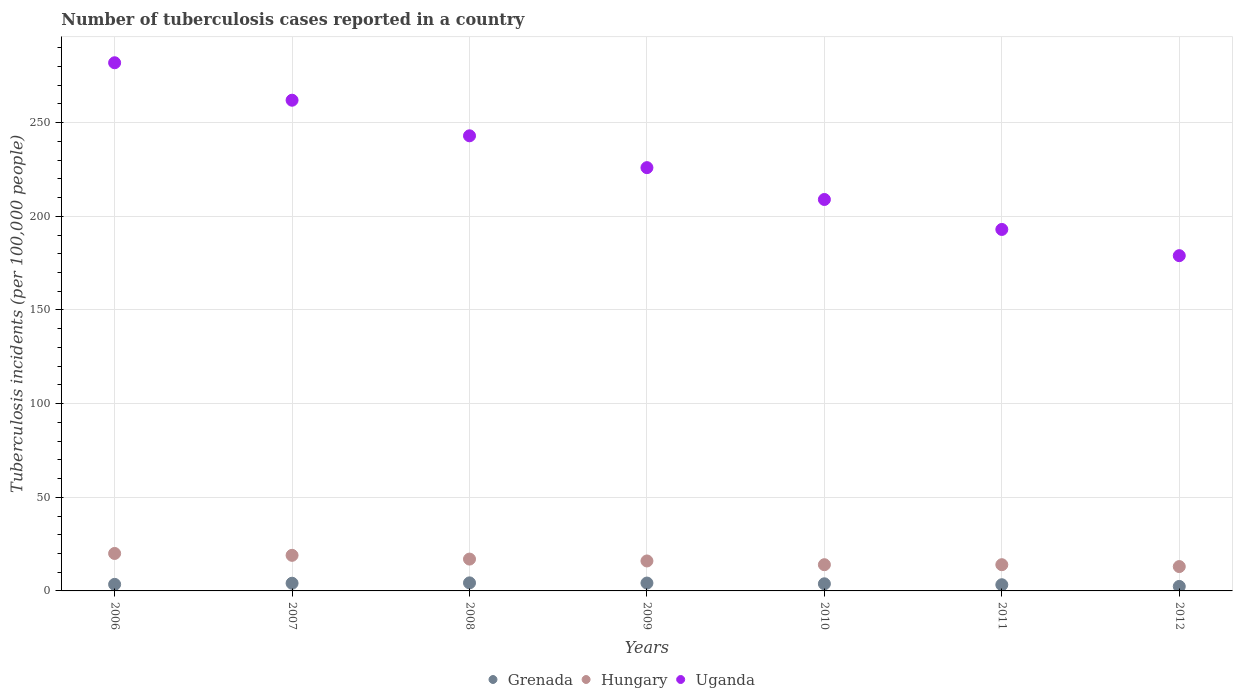How many different coloured dotlines are there?
Your answer should be compact. 3. What is the number of tuberculosis cases reported in in Hungary in 2008?
Ensure brevity in your answer.  17. Across all years, what is the maximum number of tuberculosis cases reported in in Hungary?
Give a very brief answer. 20. Across all years, what is the minimum number of tuberculosis cases reported in in Uganda?
Make the answer very short. 179. In which year was the number of tuberculosis cases reported in in Grenada maximum?
Your answer should be very brief. 2008. What is the total number of tuberculosis cases reported in in Hungary in the graph?
Give a very brief answer. 113. What is the difference between the number of tuberculosis cases reported in in Hungary in 2006 and that in 2012?
Your answer should be very brief. 7. What is the difference between the number of tuberculosis cases reported in in Uganda in 2007 and the number of tuberculosis cases reported in in Hungary in 2008?
Your answer should be compact. 245. What is the average number of tuberculosis cases reported in in Hungary per year?
Give a very brief answer. 16.14. In the year 2007, what is the difference between the number of tuberculosis cases reported in in Uganda and number of tuberculosis cases reported in in Grenada?
Your answer should be very brief. 257.9. In how many years, is the number of tuberculosis cases reported in in Grenada greater than 220?
Provide a short and direct response. 0. What is the ratio of the number of tuberculosis cases reported in in Hungary in 2007 to that in 2011?
Provide a short and direct response. 1.36. What is the difference between the highest and the second highest number of tuberculosis cases reported in in Hungary?
Keep it short and to the point. 1. What is the difference between the highest and the lowest number of tuberculosis cases reported in in Hungary?
Your response must be concise. 7. Is it the case that in every year, the sum of the number of tuberculosis cases reported in in Hungary and number of tuberculosis cases reported in in Grenada  is greater than the number of tuberculosis cases reported in in Uganda?
Offer a terse response. No. How many dotlines are there?
Keep it short and to the point. 3. What is the difference between two consecutive major ticks on the Y-axis?
Offer a very short reply. 50. Does the graph contain any zero values?
Your response must be concise. No. Does the graph contain grids?
Make the answer very short. Yes. Where does the legend appear in the graph?
Give a very brief answer. Bottom center. How many legend labels are there?
Your answer should be compact. 3. What is the title of the graph?
Keep it short and to the point. Number of tuberculosis cases reported in a country. What is the label or title of the X-axis?
Keep it short and to the point. Years. What is the label or title of the Y-axis?
Give a very brief answer. Tuberculosis incidents (per 100,0 people). What is the Tuberculosis incidents (per 100,000 people) in Hungary in 2006?
Your answer should be very brief. 20. What is the Tuberculosis incidents (per 100,000 people) of Uganda in 2006?
Your response must be concise. 282. What is the Tuberculosis incidents (per 100,000 people) of Grenada in 2007?
Give a very brief answer. 4.1. What is the Tuberculosis incidents (per 100,000 people) of Hungary in 2007?
Your answer should be very brief. 19. What is the Tuberculosis incidents (per 100,000 people) in Uganda in 2007?
Ensure brevity in your answer.  262. What is the Tuberculosis incidents (per 100,000 people) in Grenada in 2008?
Your response must be concise. 4.3. What is the Tuberculosis incidents (per 100,000 people) in Hungary in 2008?
Your response must be concise. 17. What is the Tuberculosis incidents (per 100,000 people) of Uganda in 2008?
Keep it short and to the point. 243. What is the Tuberculosis incidents (per 100,000 people) in Uganda in 2009?
Your answer should be very brief. 226. What is the Tuberculosis incidents (per 100,000 people) in Uganda in 2010?
Your response must be concise. 209. What is the Tuberculosis incidents (per 100,000 people) of Hungary in 2011?
Your response must be concise. 14. What is the Tuberculosis incidents (per 100,000 people) in Uganda in 2011?
Offer a terse response. 193. What is the Tuberculosis incidents (per 100,000 people) in Hungary in 2012?
Ensure brevity in your answer.  13. What is the Tuberculosis incidents (per 100,000 people) in Uganda in 2012?
Make the answer very short. 179. Across all years, what is the maximum Tuberculosis incidents (per 100,000 people) of Uganda?
Make the answer very short. 282. Across all years, what is the minimum Tuberculosis incidents (per 100,000 people) of Grenada?
Provide a short and direct response. 2.4. Across all years, what is the minimum Tuberculosis incidents (per 100,000 people) of Hungary?
Provide a short and direct response. 13. Across all years, what is the minimum Tuberculosis incidents (per 100,000 people) in Uganda?
Provide a succinct answer. 179. What is the total Tuberculosis incidents (per 100,000 people) of Grenada in the graph?
Your answer should be very brief. 25.6. What is the total Tuberculosis incidents (per 100,000 people) in Hungary in the graph?
Give a very brief answer. 113. What is the total Tuberculosis incidents (per 100,000 people) of Uganda in the graph?
Give a very brief answer. 1594. What is the difference between the Tuberculosis incidents (per 100,000 people) in Grenada in 2006 and that in 2007?
Provide a succinct answer. -0.6. What is the difference between the Tuberculosis incidents (per 100,000 people) in Grenada in 2006 and that in 2008?
Ensure brevity in your answer.  -0.8. What is the difference between the Tuberculosis incidents (per 100,000 people) of Uganda in 2006 and that in 2008?
Your answer should be very brief. 39. What is the difference between the Tuberculosis incidents (per 100,000 people) in Grenada in 2006 and that in 2009?
Keep it short and to the point. -0.7. What is the difference between the Tuberculosis incidents (per 100,000 people) of Hungary in 2006 and that in 2010?
Your response must be concise. 6. What is the difference between the Tuberculosis incidents (per 100,000 people) of Grenada in 2006 and that in 2011?
Keep it short and to the point. 0.2. What is the difference between the Tuberculosis incidents (per 100,000 people) in Hungary in 2006 and that in 2011?
Offer a very short reply. 6. What is the difference between the Tuberculosis incidents (per 100,000 people) in Uganda in 2006 and that in 2011?
Ensure brevity in your answer.  89. What is the difference between the Tuberculosis incidents (per 100,000 people) of Grenada in 2006 and that in 2012?
Your answer should be very brief. 1.1. What is the difference between the Tuberculosis incidents (per 100,000 people) of Hungary in 2006 and that in 2012?
Give a very brief answer. 7. What is the difference between the Tuberculosis incidents (per 100,000 people) of Uganda in 2006 and that in 2012?
Provide a short and direct response. 103. What is the difference between the Tuberculosis incidents (per 100,000 people) of Hungary in 2007 and that in 2008?
Your answer should be compact. 2. What is the difference between the Tuberculosis incidents (per 100,000 people) of Grenada in 2007 and that in 2009?
Keep it short and to the point. -0.1. What is the difference between the Tuberculosis incidents (per 100,000 people) of Hungary in 2007 and that in 2009?
Give a very brief answer. 3. What is the difference between the Tuberculosis incidents (per 100,000 people) of Uganda in 2007 and that in 2009?
Your answer should be compact. 36. What is the difference between the Tuberculosis incidents (per 100,000 people) of Uganda in 2007 and that in 2010?
Your answer should be compact. 53. What is the difference between the Tuberculosis incidents (per 100,000 people) of Grenada in 2007 and that in 2011?
Your response must be concise. 0.8. What is the difference between the Tuberculosis incidents (per 100,000 people) in Uganda in 2007 and that in 2011?
Provide a short and direct response. 69. What is the difference between the Tuberculosis incidents (per 100,000 people) of Hungary in 2007 and that in 2012?
Your answer should be compact. 6. What is the difference between the Tuberculosis incidents (per 100,000 people) in Grenada in 2008 and that in 2009?
Give a very brief answer. 0.1. What is the difference between the Tuberculosis incidents (per 100,000 people) of Grenada in 2008 and that in 2010?
Your answer should be compact. 0.5. What is the difference between the Tuberculosis incidents (per 100,000 people) of Hungary in 2008 and that in 2010?
Your response must be concise. 3. What is the difference between the Tuberculosis incidents (per 100,000 people) of Uganda in 2008 and that in 2010?
Ensure brevity in your answer.  34. What is the difference between the Tuberculosis incidents (per 100,000 people) of Hungary in 2008 and that in 2011?
Your response must be concise. 3. What is the difference between the Tuberculosis incidents (per 100,000 people) in Grenada in 2008 and that in 2012?
Give a very brief answer. 1.9. What is the difference between the Tuberculosis incidents (per 100,000 people) of Uganda in 2008 and that in 2012?
Your answer should be compact. 64. What is the difference between the Tuberculosis incidents (per 100,000 people) of Hungary in 2009 and that in 2010?
Your answer should be compact. 2. What is the difference between the Tuberculosis incidents (per 100,000 people) in Uganda in 2009 and that in 2010?
Your response must be concise. 17. What is the difference between the Tuberculosis incidents (per 100,000 people) in Grenada in 2009 and that in 2011?
Offer a terse response. 0.9. What is the difference between the Tuberculosis incidents (per 100,000 people) in Hungary in 2009 and that in 2011?
Your response must be concise. 2. What is the difference between the Tuberculosis incidents (per 100,000 people) in Uganda in 2009 and that in 2011?
Ensure brevity in your answer.  33. What is the difference between the Tuberculosis incidents (per 100,000 people) of Grenada in 2009 and that in 2012?
Give a very brief answer. 1.8. What is the difference between the Tuberculosis incidents (per 100,000 people) of Hungary in 2009 and that in 2012?
Keep it short and to the point. 3. What is the difference between the Tuberculosis incidents (per 100,000 people) of Hungary in 2010 and that in 2011?
Give a very brief answer. 0. What is the difference between the Tuberculosis incidents (per 100,000 people) in Uganda in 2010 and that in 2011?
Give a very brief answer. 16. What is the difference between the Tuberculosis incidents (per 100,000 people) of Grenada in 2010 and that in 2012?
Your answer should be compact. 1.4. What is the difference between the Tuberculosis incidents (per 100,000 people) in Grenada in 2011 and that in 2012?
Your answer should be compact. 0.9. What is the difference between the Tuberculosis incidents (per 100,000 people) of Uganda in 2011 and that in 2012?
Give a very brief answer. 14. What is the difference between the Tuberculosis incidents (per 100,000 people) of Grenada in 2006 and the Tuberculosis incidents (per 100,000 people) of Hungary in 2007?
Make the answer very short. -15.5. What is the difference between the Tuberculosis incidents (per 100,000 people) of Grenada in 2006 and the Tuberculosis incidents (per 100,000 people) of Uganda in 2007?
Make the answer very short. -258.5. What is the difference between the Tuberculosis incidents (per 100,000 people) in Hungary in 2006 and the Tuberculosis incidents (per 100,000 people) in Uganda in 2007?
Provide a succinct answer. -242. What is the difference between the Tuberculosis incidents (per 100,000 people) in Grenada in 2006 and the Tuberculosis incidents (per 100,000 people) in Hungary in 2008?
Offer a very short reply. -13.5. What is the difference between the Tuberculosis incidents (per 100,000 people) of Grenada in 2006 and the Tuberculosis incidents (per 100,000 people) of Uganda in 2008?
Your response must be concise. -239.5. What is the difference between the Tuberculosis incidents (per 100,000 people) in Hungary in 2006 and the Tuberculosis incidents (per 100,000 people) in Uganda in 2008?
Provide a short and direct response. -223. What is the difference between the Tuberculosis incidents (per 100,000 people) in Grenada in 2006 and the Tuberculosis incidents (per 100,000 people) in Uganda in 2009?
Your answer should be compact. -222.5. What is the difference between the Tuberculosis incidents (per 100,000 people) in Hungary in 2006 and the Tuberculosis incidents (per 100,000 people) in Uganda in 2009?
Offer a very short reply. -206. What is the difference between the Tuberculosis incidents (per 100,000 people) of Grenada in 2006 and the Tuberculosis incidents (per 100,000 people) of Hungary in 2010?
Provide a succinct answer. -10.5. What is the difference between the Tuberculosis incidents (per 100,000 people) in Grenada in 2006 and the Tuberculosis incidents (per 100,000 people) in Uganda in 2010?
Ensure brevity in your answer.  -205.5. What is the difference between the Tuberculosis incidents (per 100,000 people) in Hungary in 2006 and the Tuberculosis incidents (per 100,000 people) in Uganda in 2010?
Offer a very short reply. -189. What is the difference between the Tuberculosis incidents (per 100,000 people) of Grenada in 2006 and the Tuberculosis incidents (per 100,000 people) of Uganda in 2011?
Make the answer very short. -189.5. What is the difference between the Tuberculosis incidents (per 100,000 people) in Hungary in 2006 and the Tuberculosis incidents (per 100,000 people) in Uganda in 2011?
Your answer should be compact. -173. What is the difference between the Tuberculosis incidents (per 100,000 people) of Grenada in 2006 and the Tuberculosis incidents (per 100,000 people) of Uganda in 2012?
Offer a terse response. -175.5. What is the difference between the Tuberculosis incidents (per 100,000 people) in Hungary in 2006 and the Tuberculosis incidents (per 100,000 people) in Uganda in 2012?
Provide a short and direct response. -159. What is the difference between the Tuberculosis incidents (per 100,000 people) of Grenada in 2007 and the Tuberculosis incidents (per 100,000 people) of Hungary in 2008?
Provide a short and direct response. -12.9. What is the difference between the Tuberculosis incidents (per 100,000 people) of Grenada in 2007 and the Tuberculosis incidents (per 100,000 people) of Uganda in 2008?
Provide a short and direct response. -238.9. What is the difference between the Tuberculosis incidents (per 100,000 people) in Hungary in 2007 and the Tuberculosis incidents (per 100,000 people) in Uganda in 2008?
Ensure brevity in your answer.  -224. What is the difference between the Tuberculosis incidents (per 100,000 people) in Grenada in 2007 and the Tuberculosis incidents (per 100,000 people) in Hungary in 2009?
Your answer should be very brief. -11.9. What is the difference between the Tuberculosis incidents (per 100,000 people) of Grenada in 2007 and the Tuberculosis incidents (per 100,000 people) of Uganda in 2009?
Provide a succinct answer. -221.9. What is the difference between the Tuberculosis incidents (per 100,000 people) in Hungary in 2007 and the Tuberculosis incidents (per 100,000 people) in Uganda in 2009?
Offer a terse response. -207. What is the difference between the Tuberculosis incidents (per 100,000 people) of Grenada in 2007 and the Tuberculosis incidents (per 100,000 people) of Hungary in 2010?
Your answer should be very brief. -9.9. What is the difference between the Tuberculosis incidents (per 100,000 people) of Grenada in 2007 and the Tuberculosis incidents (per 100,000 people) of Uganda in 2010?
Your answer should be very brief. -204.9. What is the difference between the Tuberculosis incidents (per 100,000 people) of Hungary in 2007 and the Tuberculosis incidents (per 100,000 people) of Uganda in 2010?
Your response must be concise. -190. What is the difference between the Tuberculosis incidents (per 100,000 people) in Grenada in 2007 and the Tuberculosis incidents (per 100,000 people) in Hungary in 2011?
Provide a succinct answer. -9.9. What is the difference between the Tuberculosis incidents (per 100,000 people) in Grenada in 2007 and the Tuberculosis incidents (per 100,000 people) in Uganda in 2011?
Provide a short and direct response. -188.9. What is the difference between the Tuberculosis incidents (per 100,000 people) in Hungary in 2007 and the Tuberculosis incidents (per 100,000 people) in Uganda in 2011?
Your answer should be very brief. -174. What is the difference between the Tuberculosis incidents (per 100,000 people) of Grenada in 2007 and the Tuberculosis incidents (per 100,000 people) of Hungary in 2012?
Your response must be concise. -8.9. What is the difference between the Tuberculosis incidents (per 100,000 people) of Grenada in 2007 and the Tuberculosis incidents (per 100,000 people) of Uganda in 2012?
Keep it short and to the point. -174.9. What is the difference between the Tuberculosis incidents (per 100,000 people) of Hungary in 2007 and the Tuberculosis incidents (per 100,000 people) of Uganda in 2012?
Make the answer very short. -160. What is the difference between the Tuberculosis incidents (per 100,000 people) of Grenada in 2008 and the Tuberculosis incidents (per 100,000 people) of Hungary in 2009?
Offer a very short reply. -11.7. What is the difference between the Tuberculosis incidents (per 100,000 people) in Grenada in 2008 and the Tuberculosis incidents (per 100,000 people) in Uganda in 2009?
Your answer should be very brief. -221.7. What is the difference between the Tuberculosis incidents (per 100,000 people) in Hungary in 2008 and the Tuberculosis incidents (per 100,000 people) in Uganda in 2009?
Offer a terse response. -209. What is the difference between the Tuberculosis incidents (per 100,000 people) of Grenada in 2008 and the Tuberculosis incidents (per 100,000 people) of Uganda in 2010?
Keep it short and to the point. -204.7. What is the difference between the Tuberculosis incidents (per 100,000 people) in Hungary in 2008 and the Tuberculosis incidents (per 100,000 people) in Uganda in 2010?
Give a very brief answer. -192. What is the difference between the Tuberculosis incidents (per 100,000 people) in Grenada in 2008 and the Tuberculosis incidents (per 100,000 people) in Uganda in 2011?
Provide a succinct answer. -188.7. What is the difference between the Tuberculosis incidents (per 100,000 people) in Hungary in 2008 and the Tuberculosis incidents (per 100,000 people) in Uganda in 2011?
Your answer should be very brief. -176. What is the difference between the Tuberculosis incidents (per 100,000 people) of Grenada in 2008 and the Tuberculosis incidents (per 100,000 people) of Uganda in 2012?
Make the answer very short. -174.7. What is the difference between the Tuberculosis incidents (per 100,000 people) of Hungary in 2008 and the Tuberculosis incidents (per 100,000 people) of Uganda in 2012?
Your response must be concise. -162. What is the difference between the Tuberculosis incidents (per 100,000 people) in Grenada in 2009 and the Tuberculosis incidents (per 100,000 people) in Hungary in 2010?
Give a very brief answer. -9.8. What is the difference between the Tuberculosis incidents (per 100,000 people) of Grenada in 2009 and the Tuberculosis incidents (per 100,000 people) of Uganda in 2010?
Offer a very short reply. -204.8. What is the difference between the Tuberculosis incidents (per 100,000 people) of Hungary in 2009 and the Tuberculosis incidents (per 100,000 people) of Uganda in 2010?
Your answer should be very brief. -193. What is the difference between the Tuberculosis incidents (per 100,000 people) of Grenada in 2009 and the Tuberculosis incidents (per 100,000 people) of Hungary in 2011?
Your answer should be very brief. -9.8. What is the difference between the Tuberculosis incidents (per 100,000 people) in Grenada in 2009 and the Tuberculosis incidents (per 100,000 people) in Uganda in 2011?
Ensure brevity in your answer.  -188.8. What is the difference between the Tuberculosis incidents (per 100,000 people) of Hungary in 2009 and the Tuberculosis incidents (per 100,000 people) of Uganda in 2011?
Your response must be concise. -177. What is the difference between the Tuberculosis incidents (per 100,000 people) of Grenada in 2009 and the Tuberculosis incidents (per 100,000 people) of Uganda in 2012?
Your answer should be very brief. -174.8. What is the difference between the Tuberculosis incidents (per 100,000 people) in Hungary in 2009 and the Tuberculosis incidents (per 100,000 people) in Uganda in 2012?
Provide a succinct answer. -163. What is the difference between the Tuberculosis incidents (per 100,000 people) in Grenada in 2010 and the Tuberculosis incidents (per 100,000 people) in Uganda in 2011?
Your answer should be very brief. -189.2. What is the difference between the Tuberculosis incidents (per 100,000 people) in Hungary in 2010 and the Tuberculosis incidents (per 100,000 people) in Uganda in 2011?
Give a very brief answer. -179. What is the difference between the Tuberculosis incidents (per 100,000 people) of Grenada in 2010 and the Tuberculosis incidents (per 100,000 people) of Hungary in 2012?
Ensure brevity in your answer.  -9.2. What is the difference between the Tuberculosis incidents (per 100,000 people) in Grenada in 2010 and the Tuberculosis incidents (per 100,000 people) in Uganda in 2012?
Ensure brevity in your answer.  -175.2. What is the difference between the Tuberculosis incidents (per 100,000 people) of Hungary in 2010 and the Tuberculosis incidents (per 100,000 people) of Uganda in 2012?
Make the answer very short. -165. What is the difference between the Tuberculosis incidents (per 100,000 people) in Grenada in 2011 and the Tuberculosis incidents (per 100,000 people) in Uganda in 2012?
Keep it short and to the point. -175.7. What is the difference between the Tuberculosis incidents (per 100,000 people) of Hungary in 2011 and the Tuberculosis incidents (per 100,000 people) of Uganda in 2012?
Provide a succinct answer. -165. What is the average Tuberculosis incidents (per 100,000 people) of Grenada per year?
Provide a succinct answer. 3.66. What is the average Tuberculosis incidents (per 100,000 people) in Hungary per year?
Give a very brief answer. 16.14. What is the average Tuberculosis incidents (per 100,000 people) in Uganda per year?
Offer a very short reply. 227.71. In the year 2006, what is the difference between the Tuberculosis incidents (per 100,000 people) of Grenada and Tuberculosis incidents (per 100,000 people) of Hungary?
Your answer should be very brief. -16.5. In the year 2006, what is the difference between the Tuberculosis incidents (per 100,000 people) in Grenada and Tuberculosis incidents (per 100,000 people) in Uganda?
Give a very brief answer. -278.5. In the year 2006, what is the difference between the Tuberculosis incidents (per 100,000 people) in Hungary and Tuberculosis incidents (per 100,000 people) in Uganda?
Give a very brief answer. -262. In the year 2007, what is the difference between the Tuberculosis incidents (per 100,000 people) in Grenada and Tuberculosis incidents (per 100,000 people) in Hungary?
Offer a very short reply. -14.9. In the year 2007, what is the difference between the Tuberculosis incidents (per 100,000 people) of Grenada and Tuberculosis incidents (per 100,000 people) of Uganda?
Keep it short and to the point. -257.9. In the year 2007, what is the difference between the Tuberculosis incidents (per 100,000 people) in Hungary and Tuberculosis incidents (per 100,000 people) in Uganda?
Give a very brief answer. -243. In the year 2008, what is the difference between the Tuberculosis incidents (per 100,000 people) in Grenada and Tuberculosis incidents (per 100,000 people) in Hungary?
Your answer should be compact. -12.7. In the year 2008, what is the difference between the Tuberculosis incidents (per 100,000 people) of Grenada and Tuberculosis incidents (per 100,000 people) of Uganda?
Offer a terse response. -238.7. In the year 2008, what is the difference between the Tuberculosis incidents (per 100,000 people) in Hungary and Tuberculosis incidents (per 100,000 people) in Uganda?
Ensure brevity in your answer.  -226. In the year 2009, what is the difference between the Tuberculosis incidents (per 100,000 people) in Grenada and Tuberculosis incidents (per 100,000 people) in Hungary?
Your response must be concise. -11.8. In the year 2009, what is the difference between the Tuberculosis incidents (per 100,000 people) of Grenada and Tuberculosis incidents (per 100,000 people) of Uganda?
Your answer should be compact. -221.8. In the year 2009, what is the difference between the Tuberculosis incidents (per 100,000 people) of Hungary and Tuberculosis incidents (per 100,000 people) of Uganda?
Offer a terse response. -210. In the year 2010, what is the difference between the Tuberculosis incidents (per 100,000 people) of Grenada and Tuberculosis incidents (per 100,000 people) of Hungary?
Your answer should be very brief. -10.2. In the year 2010, what is the difference between the Tuberculosis incidents (per 100,000 people) of Grenada and Tuberculosis incidents (per 100,000 people) of Uganda?
Keep it short and to the point. -205.2. In the year 2010, what is the difference between the Tuberculosis incidents (per 100,000 people) in Hungary and Tuberculosis incidents (per 100,000 people) in Uganda?
Your response must be concise. -195. In the year 2011, what is the difference between the Tuberculosis incidents (per 100,000 people) of Grenada and Tuberculosis incidents (per 100,000 people) of Uganda?
Keep it short and to the point. -189.7. In the year 2011, what is the difference between the Tuberculosis incidents (per 100,000 people) of Hungary and Tuberculosis incidents (per 100,000 people) of Uganda?
Give a very brief answer. -179. In the year 2012, what is the difference between the Tuberculosis incidents (per 100,000 people) in Grenada and Tuberculosis incidents (per 100,000 people) in Uganda?
Provide a short and direct response. -176.6. In the year 2012, what is the difference between the Tuberculosis incidents (per 100,000 people) of Hungary and Tuberculosis incidents (per 100,000 people) of Uganda?
Ensure brevity in your answer.  -166. What is the ratio of the Tuberculosis incidents (per 100,000 people) of Grenada in 2006 to that in 2007?
Your answer should be very brief. 0.85. What is the ratio of the Tuberculosis incidents (per 100,000 people) of Hungary in 2006 to that in 2007?
Ensure brevity in your answer.  1.05. What is the ratio of the Tuberculosis incidents (per 100,000 people) of Uganda in 2006 to that in 2007?
Provide a succinct answer. 1.08. What is the ratio of the Tuberculosis incidents (per 100,000 people) of Grenada in 2006 to that in 2008?
Give a very brief answer. 0.81. What is the ratio of the Tuberculosis incidents (per 100,000 people) in Hungary in 2006 to that in 2008?
Your answer should be compact. 1.18. What is the ratio of the Tuberculosis incidents (per 100,000 people) of Uganda in 2006 to that in 2008?
Ensure brevity in your answer.  1.16. What is the ratio of the Tuberculosis incidents (per 100,000 people) of Uganda in 2006 to that in 2009?
Provide a succinct answer. 1.25. What is the ratio of the Tuberculosis incidents (per 100,000 people) in Grenada in 2006 to that in 2010?
Keep it short and to the point. 0.92. What is the ratio of the Tuberculosis incidents (per 100,000 people) in Hungary in 2006 to that in 2010?
Make the answer very short. 1.43. What is the ratio of the Tuberculosis incidents (per 100,000 people) in Uganda in 2006 to that in 2010?
Offer a terse response. 1.35. What is the ratio of the Tuberculosis incidents (per 100,000 people) in Grenada in 2006 to that in 2011?
Your answer should be compact. 1.06. What is the ratio of the Tuberculosis incidents (per 100,000 people) of Hungary in 2006 to that in 2011?
Provide a succinct answer. 1.43. What is the ratio of the Tuberculosis incidents (per 100,000 people) in Uganda in 2006 to that in 2011?
Your answer should be compact. 1.46. What is the ratio of the Tuberculosis incidents (per 100,000 people) of Grenada in 2006 to that in 2012?
Your answer should be very brief. 1.46. What is the ratio of the Tuberculosis incidents (per 100,000 people) of Hungary in 2006 to that in 2012?
Make the answer very short. 1.54. What is the ratio of the Tuberculosis incidents (per 100,000 people) of Uganda in 2006 to that in 2012?
Offer a very short reply. 1.58. What is the ratio of the Tuberculosis incidents (per 100,000 people) in Grenada in 2007 to that in 2008?
Give a very brief answer. 0.95. What is the ratio of the Tuberculosis incidents (per 100,000 people) of Hungary in 2007 to that in 2008?
Keep it short and to the point. 1.12. What is the ratio of the Tuberculosis incidents (per 100,000 people) in Uganda in 2007 to that in 2008?
Your response must be concise. 1.08. What is the ratio of the Tuberculosis incidents (per 100,000 people) of Grenada in 2007 to that in 2009?
Provide a succinct answer. 0.98. What is the ratio of the Tuberculosis incidents (per 100,000 people) in Hungary in 2007 to that in 2009?
Your answer should be compact. 1.19. What is the ratio of the Tuberculosis incidents (per 100,000 people) of Uganda in 2007 to that in 2009?
Your answer should be very brief. 1.16. What is the ratio of the Tuberculosis incidents (per 100,000 people) in Grenada in 2007 to that in 2010?
Provide a succinct answer. 1.08. What is the ratio of the Tuberculosis incidents (per 100,000 people) of Hungary in 2007 to that in 2010?
Offer a terse response. 1.36. What is the ratio of the Tuberculosis incidents (per 100,000 people) of Uganda in 2007 to that in 2010?
Your response must be concise. 1.25. What is the ratio of the Tuberculosis incidents (per 100,000 people) of Grenada in 2007 to that in 2011?
Keep it short and to the point. 1.24. What is the ratio of the Tuberculosis incidents (per 100,000 people) in Hungary in 2007 to that in 2011?
Keep it short and to the point. 1.36. What is the ratio of the Tuberculosis incidents (per 100,000 people) of Uganda in 2007 to that in 2011?
Offer a very short reply. 1.36. What is the ratio of the Tuberculosis incidents (per 100,000 people) in Grenada in 2007 to that in 2012?
Ensure brevity in your answer.  1.71. What is the ratio of the Tuberculosis incidents (per 100,000 people) in Hungary in 2007 to that in 2012?
Provide a short and direct response. 1.46. What is the ratio of the Tuberculosis incidents (per 100,000 people) in Uganda in 2007 to that in 2012?
Offer a terse response. 1.46. What is the ratio of the Tuberculosis incidents (per 100,000 people) in Grenada in 2008 to that in 2009?
Give a very brief answer. 1.02. What is the ratio of the Tuberculosis incidents (per 100,000 people) in Hungary in 2008 to that in 2009?
Make the answer very short. 1.06. What is the ratio of the Tuberculosis incidents (per 100,000 people) of Uganda in 2008 to that in 2009?
Your response must be concise. 1.08. What is the ratio of the Tuberculosis incidents (per 100,000 people) of Grenada in 2008 to that in 2010?
Your answer should be compact. 1.13. What is the ratio of the Tuberculosis incidents (per 100,000 people) of Hungary in 2008 to that in 2010?
Provide a succinct answer. 1.21. What is the ratio of the Tuberculosis incidents (per 100,000 people) in Uganda in 2008 to that in 2010?
Provide a succinct answer. 1.16. What is the ratio of the Tuberculosis incidents (per 100,000 people) of Grenada in 2008 to that in 2011?
Offer a terse response. 1.3. What is the ratio of the Tuberculosis incidents (per 100,000 people) in Hungary in 2008 to that in 2011?
Offer a very short reply. 1.21. What is the ratio of the Tuberculosis incidents (per 100,000 people) in Uganda in 2008 to that in 2011?
Offer a very short reply. 1.26. What is the ratio of the Tuberculosis incidents (per 100,000 people) of Grenada in 2008 to that in 2012?
Your answer should be very brief. 1.79. What is the ratio of the Tuberculosis incidents (per 100,000 people) of Hungary in 2008 to that in 2012?
Make the answer very short. 1.31. What is the ratio of the Tuberculosis incidents (per 100,000 people) of Uganda in 2008 to that in 2012?
Your answer should be compact. 1.36. What is the ratio of the Tuberculosis incidents (per 100,000 people) of Grenada in 2009 to that in 2010?
Make the answer very short. 1.11. What is the ratio of the Tuberculosis incidents (per 100,000 people) in Hungary in 2009 to that in 2010?
Offer a very short reply. 1.14. What is the ratio of the Tuberculosis incidents (per 100,000 people) of Uganda in 2009 to that in 2010?
Make the answer very short. 1.08. What is the ratio of the Tuberculosis incidents (per 100,000 people) of Grenada in 2009 to that in 2011?
Give a very brief answer. 1.27. What is the ratio of the Tuberculosis incidents (per 100,000 people) in Hungary in 2009 to that in 2011?
Keep it short and to the point. 1.14. What is the ratio of the Tuberculosis incidents (per 100,000 people) in Uganda in 2009 to that in 2011?
Keep it short and to the point. 1.17. What is the ratio of the Tuberculosis incidents (per 100,000 people) in Hungary in 2009 to that in 2012?
Provide a succinct answer. 1.23. What is the ratio of the Tuberculosis incidents (per 100,000 people) of Uganda in 2009 to that in 2012?
Your response must be concise. 1.26. What is the ratio of the Tuberculosis incidents (per 100,000 people) of Grenada in 2010 to that in 2011?
Your answer should be very brief. 1.15. What is the ratio of the Tuberculosis incidents (per 100,000 people) of Hungary in 2010 to that in 2011?
Provide a succinct answer. 1. What is the ratio of the Tuberculosis incidents (per 100,000 people) in Uganda in 2010 to that in 2011?
Offer a very short reply. 1.08. What is the ratio of the Tuberculosis incidents (per 100,000 people) of Grenada in 2010 to that in 2012?
Your answer should be compact. 1.58. What is the ratio of the Tuberculosis incidents (per 100,000 people) of Hungary in 2010 to that in 2012?
Your answer should be compact. 1.08. What is the ratio of the Tuberculosis incidents (per 100,000 people) of Uganda in 2010 to that in 2012?
Your answer should be very brief. 1.17. What is the ratio of the Tuberculosis incidents (per 100,000 people) of Grenada in 2011 to that in 2012?
Ensure brevity in your answer.  1.38. What is the ratio of the Tuberculosis incidents (per 100,000 people) of Hungary in 2011 to that in 2012?
Offer a terse response. 1.08. What is the ratio of the Tuberculosis incidents (per 100,000 people) in Uganda in 2011 to that in 2012?
Offer a terse response. 1.08. What is the difference between the highest and the second highest Tuberculosis incidents (per 100,000 people) of Grenada?
Your answer should be compact. 0.1. What is the difference between the highest and the second highest Tuberculosis incidents (per 100,000 people) in Uganda?
Offer a terse response. 20. What is the difference between the highest and the lowest Tuberculosis incidents (per 100,000 people) in Hungary?
Your answer should be compact. 7. What is the difference between the highest and the lowest Tuberculosis incidents (per 100,000 people) of Uganda?
Ensure brevity in your answer.  103. 